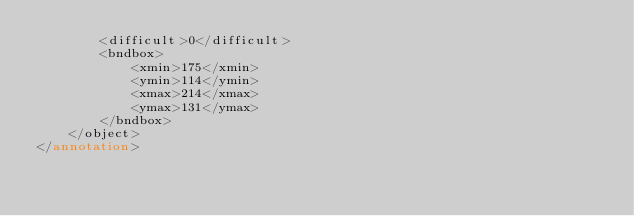Convert code to text. <code><loc_0><loc_0><loc_500><loc_500><_XML_>        <difficult>0</difficult>
        <bndbox>
            <xmin>175</xmin>
            <ymin>114</ymin>
            <xmax>214</xmax>
            <ymax>131</ymax>
        </bndbox>
    </object>
</annotation></code> 